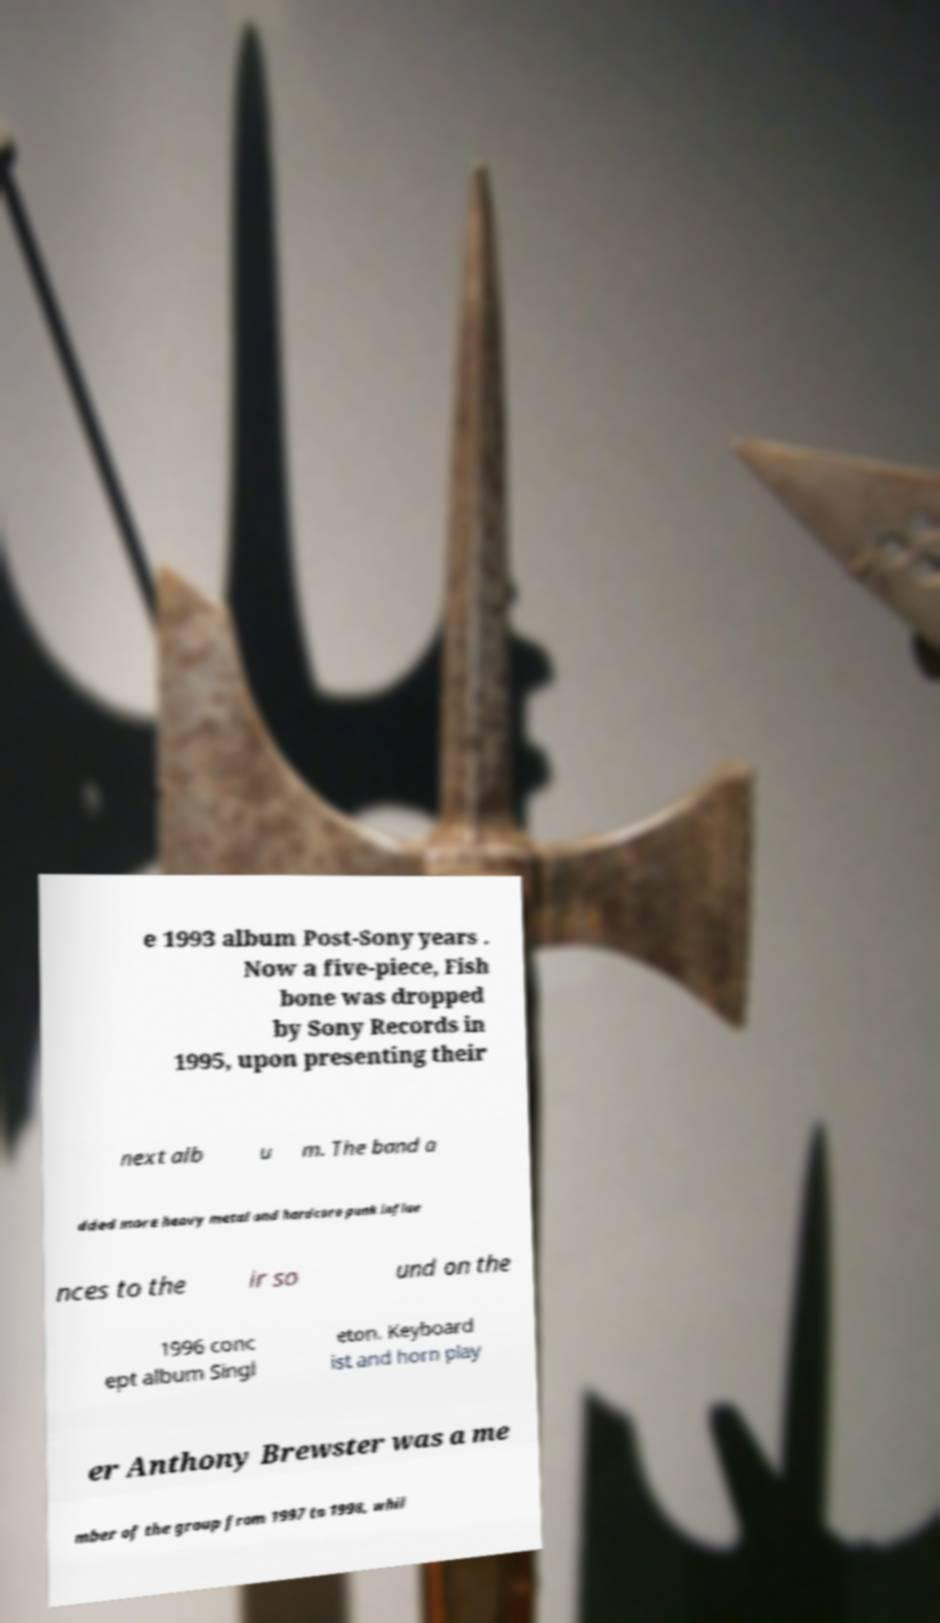What messages or text are displayed in this image? I need them in a readable, typed format. e 1993 album Post-Sony years . Now a five-piece, Fish bone was dropped by Sony Records in 1995, upon presenting their next alb u m. The band a dded more heavy metal and hardcore punk influe nces to the ir so und on the 1996 conc ept album Singl eton. Keyboard ist and horn play er Anthony Brewster was a me mber of the group from 1997 to 1998, whil 